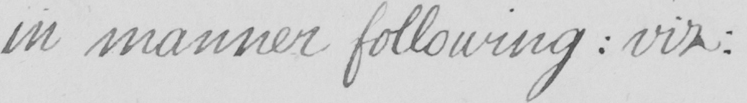Please transcribe the handwritten text in this image. in manner following  :  viz : 